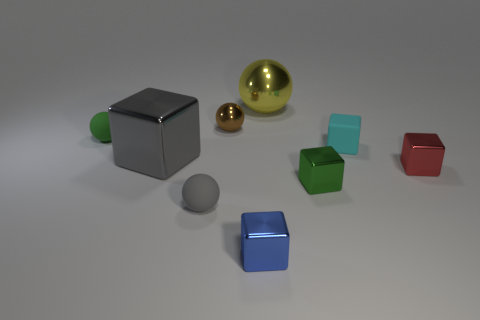Subtract all tiny green cubes. How many cubes are left? 4 Add 1 blue shiny blocks. How many objects exist? 10 Subtract all green spheres. How many spheres are left? 3 Subtract 3 blocks. How many blocks are left? 2 Add 9 small blue shiny objects. How many small blue shiny objects exist? 10 Subtract 0 green cylinders. How many objects are left? 9 Subtract all balls. How many objects are left? 5 Subtract all brown cubes. Subtract all green balls. How many cubes are left? 5 Subtract all blue matte things. Subtract all gray spheres. How many objects are left? 8 Add 7 brown metallic balls. How many brown metallic balls are left? 8 